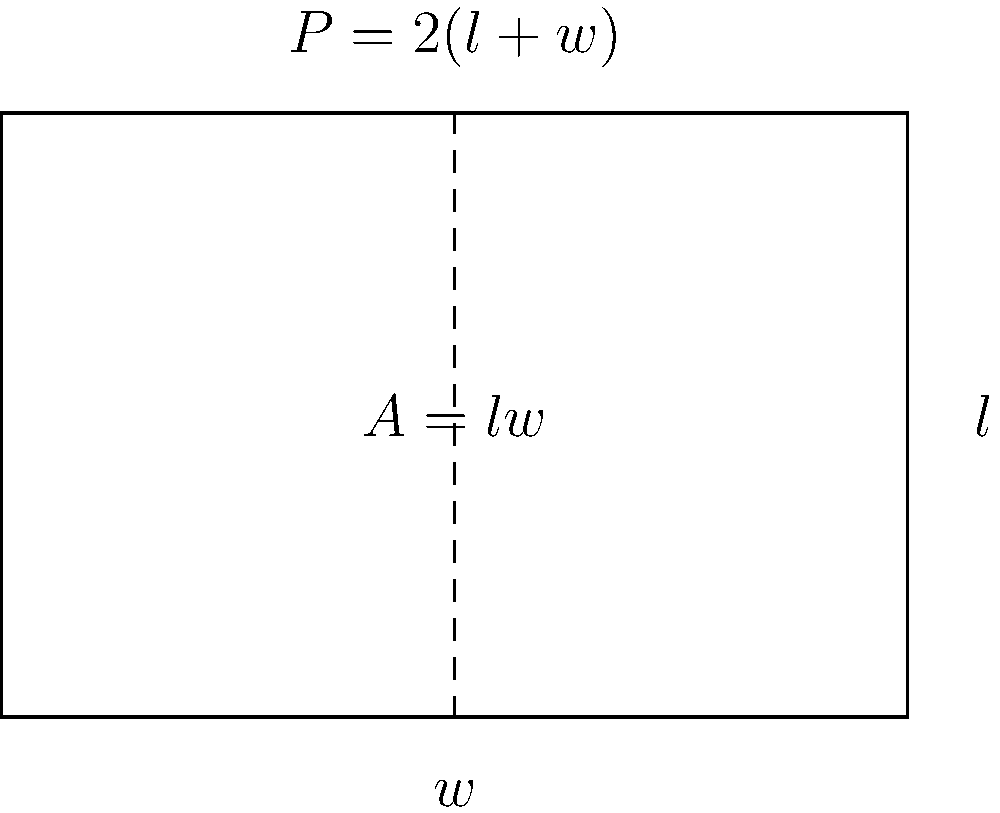As a basket maker, you want to optimize your market stall's display area. Given that the perimeter of your rectangular stall is fixed at 20 feet, what dimensions (length and width) will maximize the display area for your handmade baskets? Let's approach this step-by-step:

1) Let $l$ be the length and $w$ be the width of the rectangular stall.

2) The perimeter $P$ is given as 20 feet:
   $$P = 2l + 2w = 20$$

3) We can express $l$ in terms of $w$:
   $$l = 10 - w$$

4) The area $A$ of the stall is given by:
   $$A = lw = (10-w)w = 10w - w^2$$

5) To find the maximum area, we need to find the value of $w$ where $\frac{dA}{dw} = 0$:
   $$\frac{dA}{dw} = 10 - 2w$$

6) Setting this equal to zero:
   $$10 - 2w = 0$$
   $$2w = 10$$
   $$w = 5$$

7) Since $l = 10 - w$, when $w = 5$, $l = 5$ as well.

8) To confirm this is a maximum, we can check that $\frac{d^2A}{dw^2} < 0$:
   $$\frac{d^2A}{dw^2} = -2$$, which is indeed negative.

Therefore, the stall's area is maximized when it's a square with both length and width equal to 5 feet.
Answer: Length = 5 feet, Width = 5 feet 